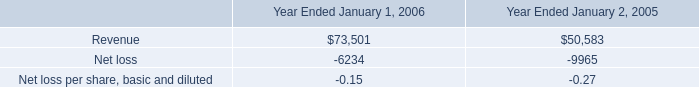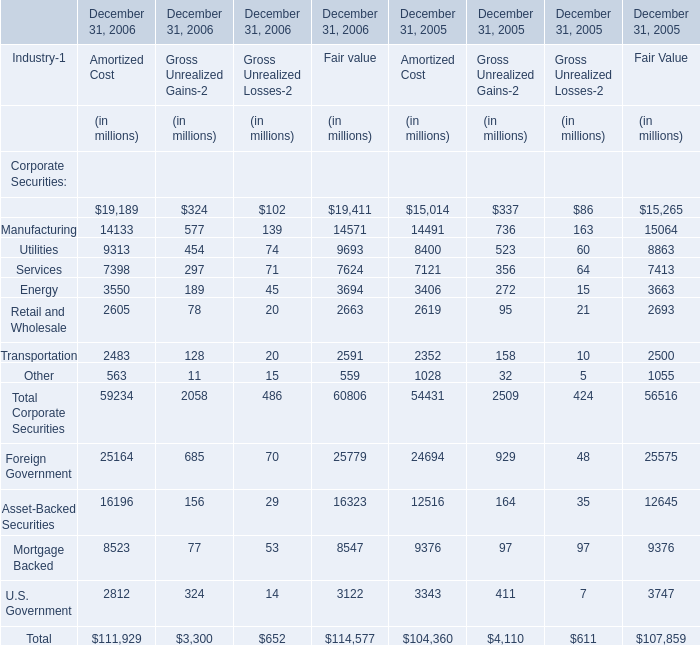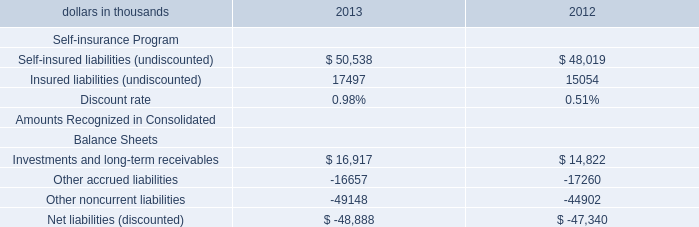what was the percent of the growth in the revenues from 2005 to 2006 
Computations: ((73501 - 50583) / 50583)
Answer: 0.45308. what was the percentage change in net loss between 2005 and 2006? 
Computations: ((-6234 - -9965) / 9965)
Answer: 0.37441. 